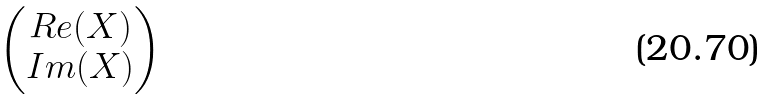Convert formula to latex. <formula><loc_0><loc_0><loc_500><loc_500>\begin{pmatrix} R e ( X ) \\ I m ( X ) \end{pmatrix}</formula> 